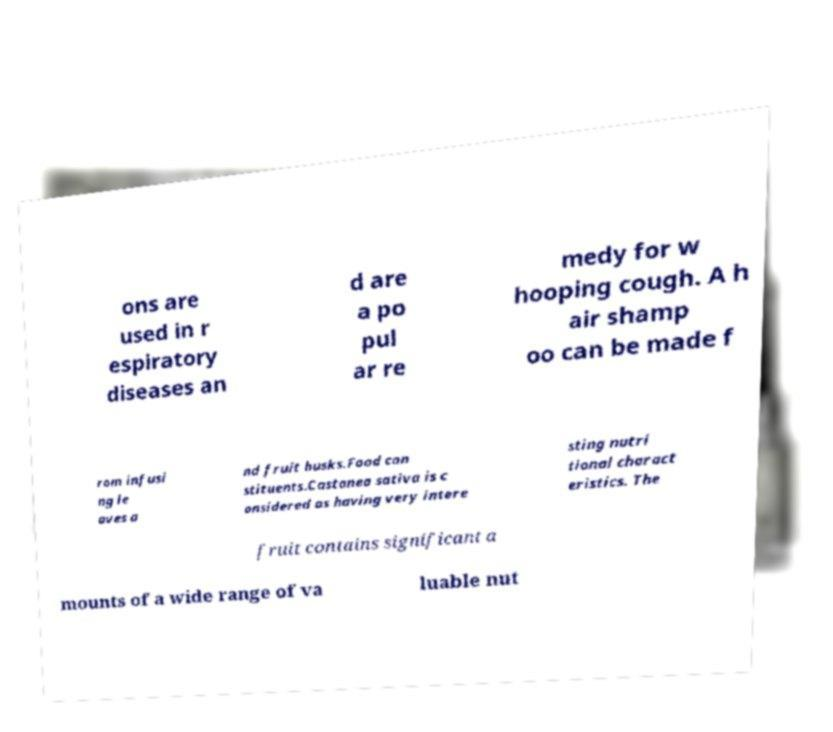Can you read and provide the text displayed in the image?This photo seems to have some interesting text. Can you extract and type it out for me? ons are used in r espiratory diseases an d are a po pul ar re medy for w hooping cough. A h air shamp oo can be made f rom infusi ng le aves a nd fruit husks.Food con stituents.Castanea sativa is c onsidered as having very intere sting nutri tional charact eristics. The fruit contains significant a mounts of a wide range of va luable nut 